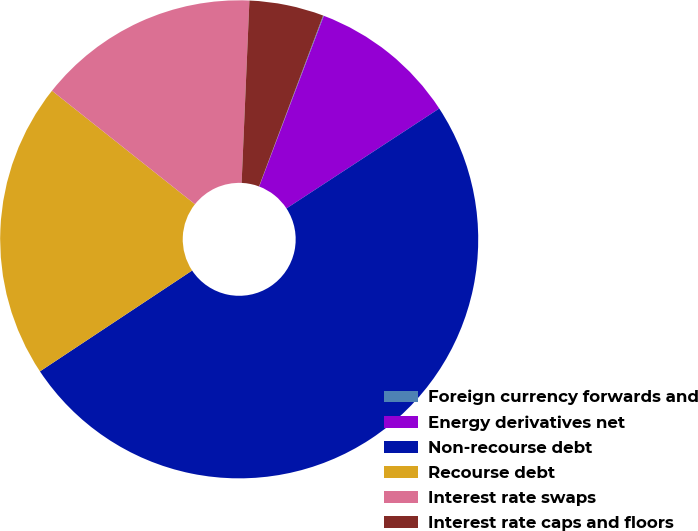<chart> <loc_0><loc_0><loc_500><loc_500><pie_chart><fcel>Foreign currency forwards and<fcel>Energy derivatives net<fcel>Non-recourse debt<fcel>Recourse debt<fcel>Interest rate swaps<fcel>Interest rate caps and floors<nl><fcel>0.05%<fcel>10.02%<fcel>49.9%<fcel>19.99%<fcel>15.0%<fcel>5.03%<nl></chart> 